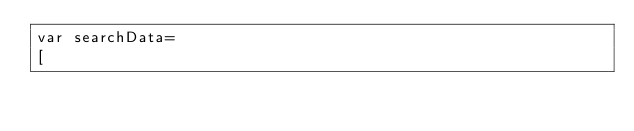<code> <loc_0><loc_0><loc_500><loc_500><_JavaScript_>var searchData=
[</code> 